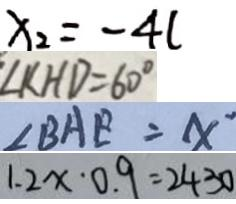Convert formula to latex. <formula><loc_0><loc_0><loc_500><loc_500>x _ { 2 } = - 4 l 
 \angle K H D = 6 0 ^ { \circ } 
 \angle B A E = x ^ { \prime } 
 1 . 2 x \cdot 0 . 9 = 2 4 3 0</formula> 